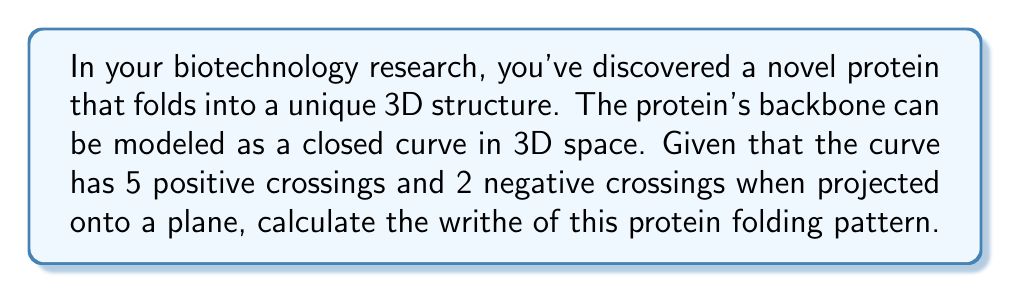Show me your answer to this math problem. To calculate the writhe of a protein folding pattern, we need to understand the concept of writhe in knot theory and how it applies to protein structures. Let's break this down step-by-step:

1) The writhe of a knot or link is a measure of the coiling of the curve in three-dimensional space. It's calculated by summing the signs of all crossings in a planar projection of the curve.

2) In this case, we have a protein backbone modeled as a closed curve in 3D space. When projected onto a plane, it forms a diagram with crossings.

3) We're given two pieces of information:
   - There are 5 positive crossings
   - There are 2 negative crossings

4) The formula for writhe (W) is:

   $$W = \sum_{i} \epsilon_i$$

   where $\epsilon_i$ is the sign of the i-th crossing (+1 for positive, -1 for negative).

5) Let's sum up our crossings:
   - 5 positive crossings contribute: $5 \times (+1) = +5$
   - 2 negative crossings contribute: $2 \times (-1) = -2$

6) Adding these together:

   $$W = (+5) + (-2) = 3$$

Therefore, the writhe of this protein folding pattern is 3.
Answer: 3 